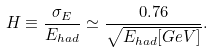Convert formula to latex. <formula><loc_0><loc_0><loc_500><loc_500>H \equiv \frac { \sigma _ { E } } { E _ { h a d } } \simeq \frac { 0 . 7 6 } { \sqrt { E _ { h a d } [ G e V ] } } .</formula> 